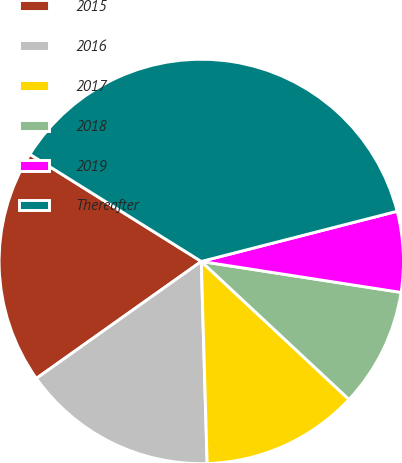Convert chart. <chart><loc_0><loc_0><loc_500><loc_500><pie_chart><fcel>2015<fcel>2016<fcel>2017<fcel>2018<fcel>2019<fcel>Thereafter<nl><fcel>18.71%<fcel>15.64%<fcel>12.58%<fcel>9.51%<fcel>6.44%<fcel>37.11%<nl></chart> 